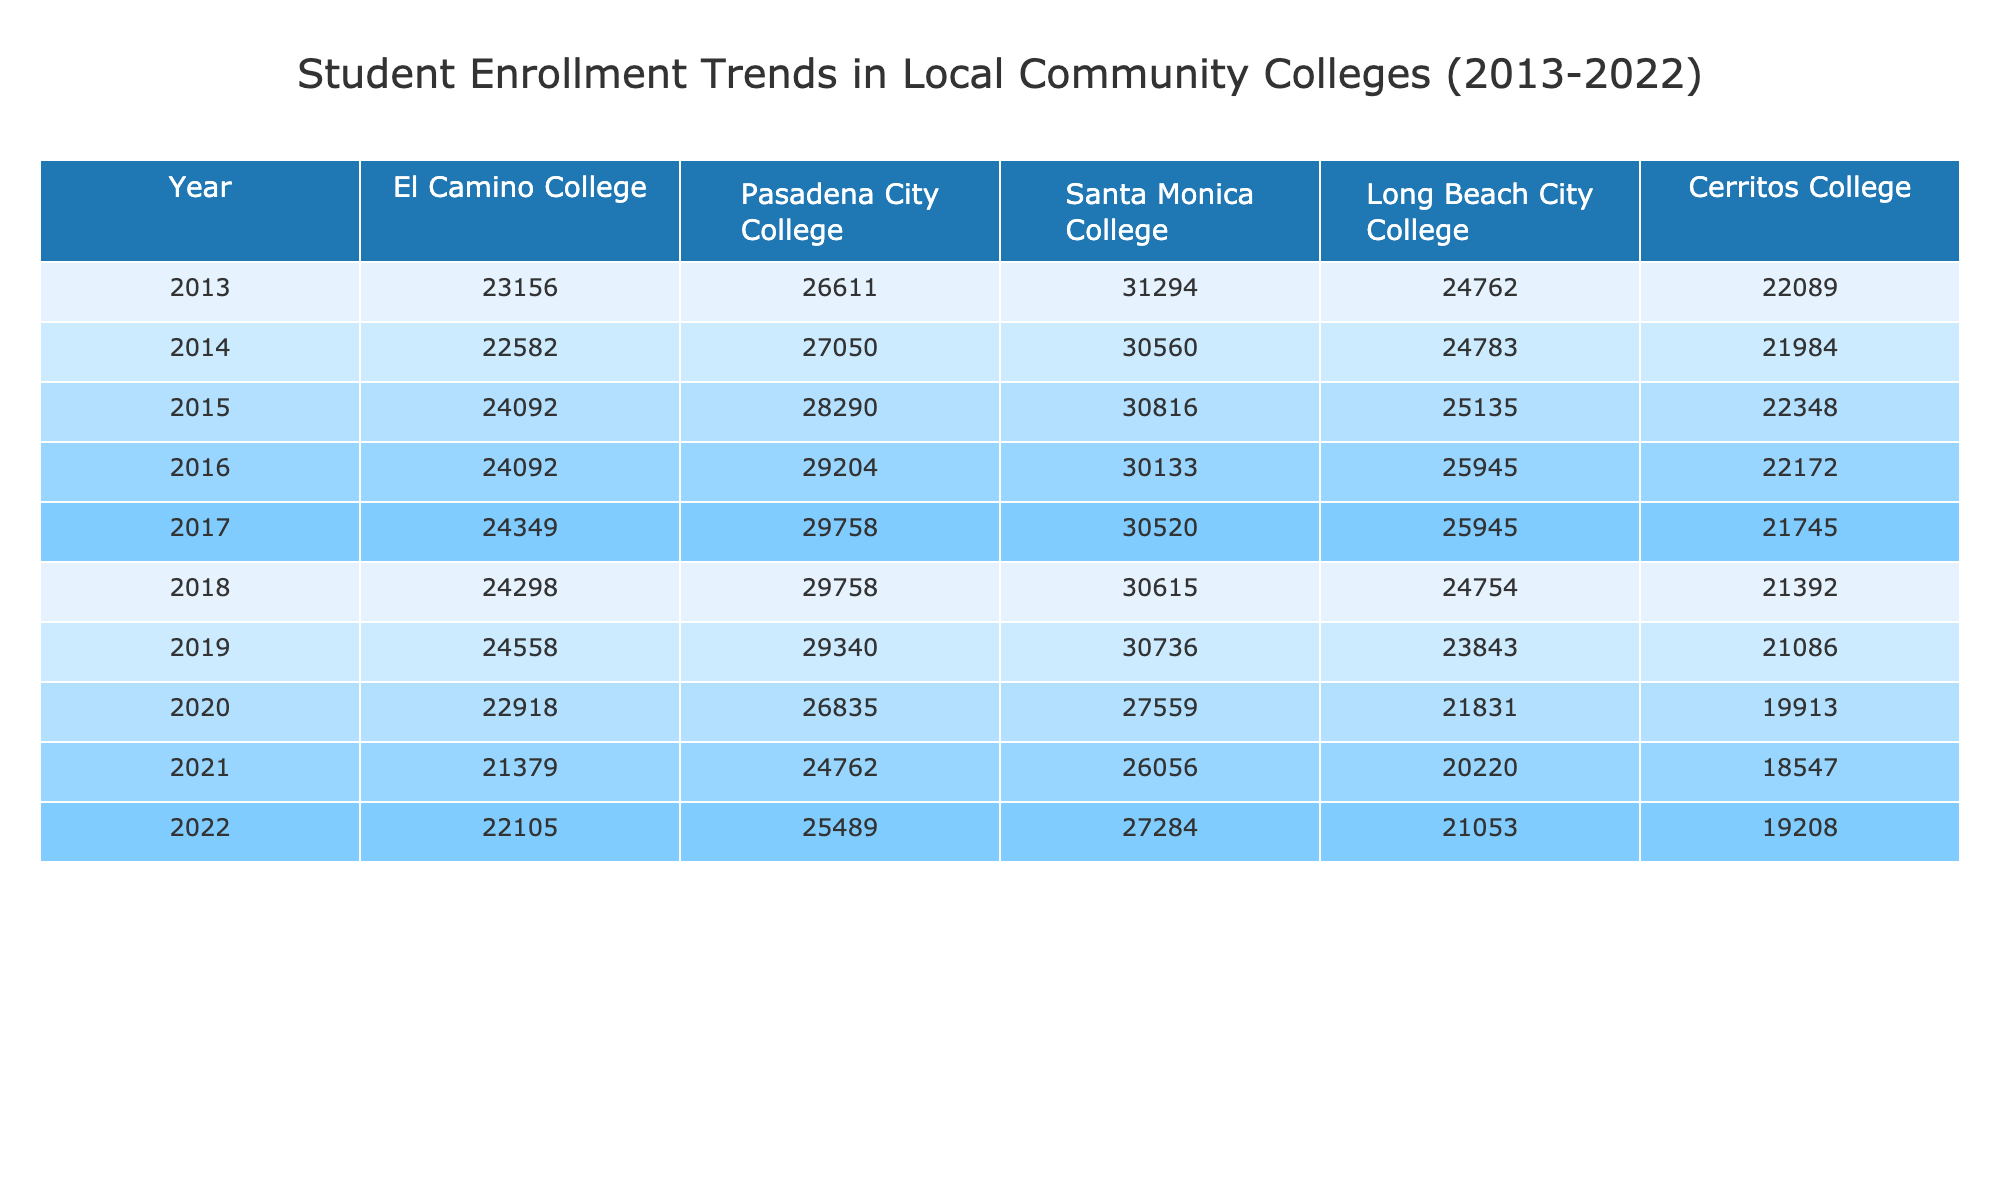What was the enrollment at El Camino College in 2019? The table shows the enrollment for El Camino College in 2019 as 24558.
Answer: 24558 Which college had the highest enrollment in 2016? Looking through the 2016 enrollment data for all colleges, Santa Monica College had 30133, which is the highest compared to other colleges.
Answer: Santa Monica College What is the average enrollment for Cerritos College over the ten years? The sum of Cerritos College enrollments from 2013 to 2022 is 22089 + 21984 + 22348 + 22172 + 21745 + 21392 + 21086 + 19913 + 19208 = 197627. Dividing by 10 gives an average of 19762.7 when rounded to the nearest whole number.
Answer: 19763 Did the enrollment at Pasadena City College increase from 2013 to 2022? By comparing the enrollment figures in 2013 (26611) and in 2022 (25489), we see a decrease from 26611 to 25489.
Answer: No What was the percentage decrease in enrollment at Long Beach City College from 2013 to 2021? The enrollment for Long Beach City College in 2013 was 24762, and in 2021 it was 20220. The decrease is 24762 - 20220 = 4532. The percentage decrease is (4532 / 24762) * 100, which is approximately 18.3%.
Answer: 18.3% Which college saw the most significant drop in enrollment from 2020 to 2021? For 2020, Pasadena City College had 26835 and dropped to 24762 in 2021, a decrease of 2063. For the same years, Long Beach City College dropped from 21831 to 20220, representing a 1611 decrease. The largest drop is 2063 for Pasadena City College.
Answer: Pasadena City College Calculate the total enrollment for all colleges in 2015. Adding the enrollment figures from the table for 2015: 24092 (El Camino) + 28290 (Pasadena) + 30816 (Santa Monica) + 25135 (Long Beach) + 22348 (Cerritos) results in a total of 128681.
Answer: 128681 Which college had a consistent decline in enrollment from 2019 to 2021? Evaluating the data for both 2019 and 2021, Cerritos College shows a decline as follows: 21086 in 2019 decreased to 18547 in 2021, indicating a consistent decline in enrollment over these years.
Answer: Cerritos College What was the overall trend for Santa Monica College from 2013 to 2022? From the table, Santa Monica College started with 31294 in 2013 and had varying enrollment figures reaching 27284 in 2022. Starting high and declining till 2018, then having minor variations until 2022 suggests an overall decrease over the years.
Answer: Overall decrease 